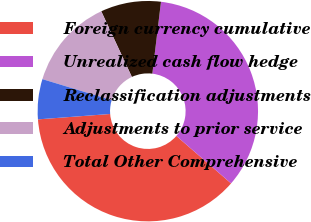<chart> <loc_0><loc_0><loc_500><loc_500><pie_chart><fcel>Foreign currency cumulative<fcel>Unrealized cash flow hedge<fcel>Reclassification adjustments<fcel>Adjustments to prior service<fcel>Total Other Comprehensive<nl><fcel>37.44%<fcel>34.47%<fcel>8.85%<fcel>13.36%<fcel>5.88%<nl></chart> 